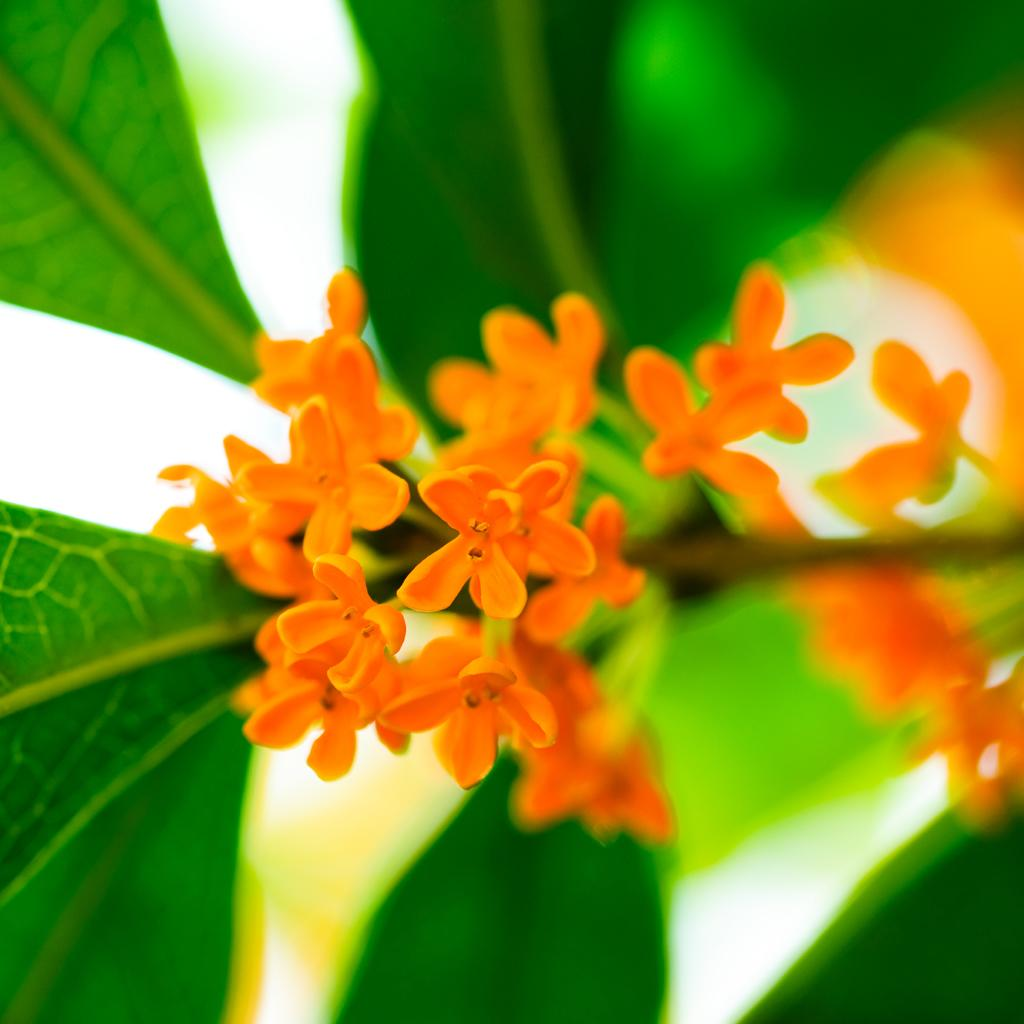What type of flowers are present in the image? There are small orange color flowers in the image. What color are the leaves surrounding the flowers? The leaves around the flowers are green. What type of bed is visible in the image? There is no bed present in the image; it only features small orange color flowers and green leaves. What kind of treatment is being administered to the flowers in the image? There is no treatment being administered to the flowers in the image; they are simply growing and surrounded by green leaves. 